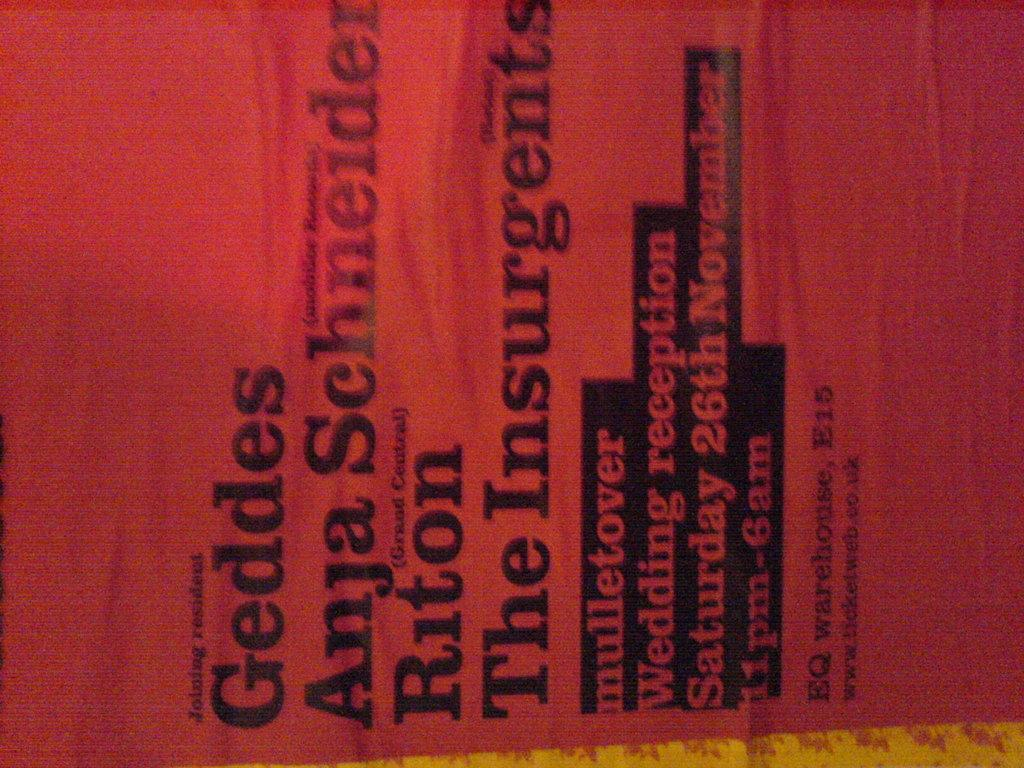Provide a one-sentence caption for the provided image. Red cover showing the word "Geddes" on the top. 